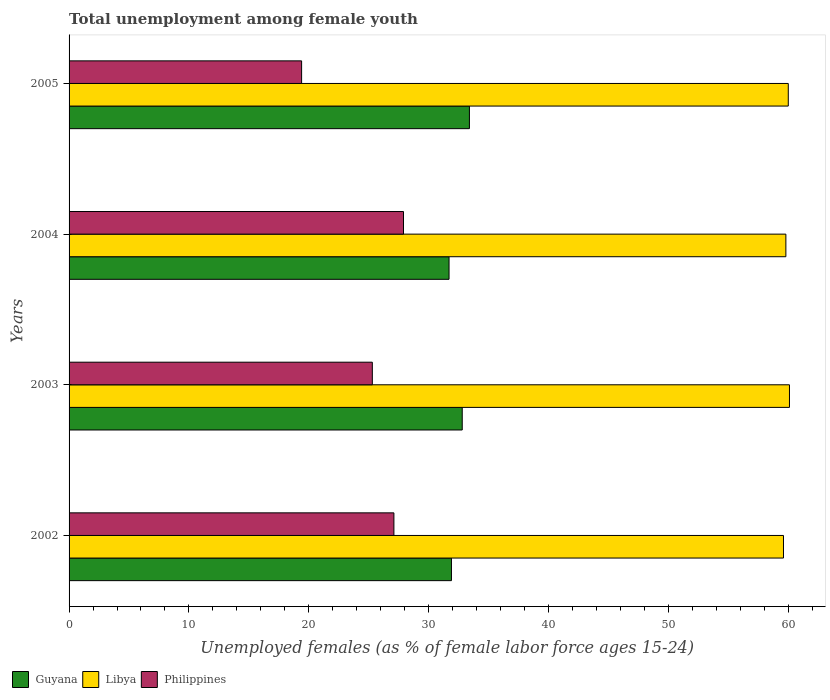How many groups of bars are there?
Make the answer very short. 4. Are the number of bars per tick equal to the number of legend labels?
Your response must be concise. Yes. What is the label of the 4th group of bars from the top?
Make the answer very short. 2002. What is the percentage of unemployed females in in Libya in 2003?
Provide a short and direct response. 60.1. Across all years, what is the maximum percentage of unemployed females in in Guyana?
Make the answer very short. 33.4. Across all years, what is the minimum percentage of unemployed females in in Philippines?
Provide a short and direct response. 19.4. In which year was the percentage of unemployed females in in Libya maximum?
Provide a short and direct response. 2003. What is the total percentage of unemployed females in in Libya in the graph?
Your answer should be compact. 239.5. What is the difference between the percentage of unemployed females in in Philippines in 2003 and that in 2004?
Your answer should be compact. -2.6. What is the average percentage of unemployed females in in Philippines per year?
Make the answer very short. 24.92. In the year 2002, what is the difference between the percentage of unemployed females in in Libya and percentage of unemployed females in in Philippines?
Your response must be concise. 32.5. In how many years, is the percentage of unemployed females in in Guyana greater than 16 %?
Your answer should be very brief. 4. What is the ratio of the percentage of unemployed females in in Guyana in 2003 to that in 2004?
Give a very brief answer. 1.03. Is the difference between the percentage of unemployed females in in Libya in 2002 and 2004 greater than the difference between the percentage of unemployed females in in Philippines in 2002 and 2004?
Your answer should be very brief. Yes. What is the difference between the highest and the second highest percentage of unemployed females in in Philippines?
Offer a terse response. 0.8. What is the difference between the highest and the lowest percentage of unemployed females in in Philippines?
Your answer should be compact. 8.5. In how many years, is the percentage of unemployed females in in Libya greater than the average percentage of unemployed females in in Libya taken over all years?
Keep it short and to the point. 2. Is the sum of the percentage of unemployed females in in Libya in 2003 and 2004 greater than the maximum percentage of unemployed females in in Guyana across all years?
Offer a terse response. Yes. What does the 3rd bar from the top in 2005 represents?
Your answer should be compact. Guyana. What does the 1st bar from the bottom in 2005 represents?
Give a very brief answer. Guyana. How many bars are there?
Offer a very short reply. 12. How many years are there in the graph?
Offer a very short reply. 4. What is the difference between two consecutive major ticks on the X-axis?
Keep it short and to the point. 10. Are the values on the major ticks of X-axis written in scientific E-notation?
Provide a short and direct response. No. Does the graph contain grids?
Give a very brief answer. No. Where does the legend appear in the graph?
Provide a succinct answer. Bottom left. What is the title of the graph?
Give a very brief answer. Total unemployment among female youth. Does "San Marino" appear as one of the legend labels in the graph?
Provide a short and direct response. No. What is the label or title of the X-axis?
Your answer should be very brief. Unemployed females (as % of female labor force ages 15-24). What is the Unemployed females (as % of female labor force ages 15-24) of Guyana in 2002?
Ensure brevity in your answer.  31.9. What is the Unemployed females (as % of female labor force ages 15-24) in Libya in 2002?
Offer a very short reply. 59.6. What is the Unemployed females (as % of female labor force ages 15-24) of Philippines in 2002?
Provide a succinct answer. 27.1. What is the Unemployed females (as % of female labor force ages 15-24) of Guyana in 2003?
Provide a short and direct response. 32.8. What is the Unemployed females (as % of female labor force ages 15-24) in Libya in 2003?
Your answer should be very brief. 60.1. What is the Unemployed females (as % of female labor force ages 15-24) of Philippines in 2003?
Your answer should be compact. 25.3. What is the Unemployed females (as % of female labor force ages 15-24) of Guyana in 2004?
Offer a terse response. 31.7. What is the Unemployed females (as % of female labor force ages 15-24) of Libya in 2004?
Offer a very short reply. 59.8. What is the Unemployed females (as % of female labor force ages 15-24) of Philippines in 2004?
Provide a short and direct response. 27.9. What is the Unemployed females (as % of female labor force ages 15-24) of Guyana in 2005?
Offer a very short reply. 33.4. What is the Unemployed females (as % of female labor force ages 15-24) of Libya in 2005?
Give a very brief answer. 60. What is the Unemployed females (as % of female labor force ages 15-24) of Philippines in 2005?
Ensure brevity in your answer.  19.4. Across all years, what is the maximum Unemployed females (as % of female labor force ages 15-24) in Guyana?
Your response must be concise. 33.4. Across all years, what is the maximum Unemployed females (as % of female labor force ages 15-24) in Libya?
Keep it short and to the point. 60.1. Across all years, what is the maximum Unemployed females (as % of female labor force ages 15-24) in Philippines?
Make the answer very short. 27.9. Across all years, what is the minimum Unemployed females (as % of female labor force ages 15-24) in Guyana?
Offer a very short reply. 31.7. Across all years, what is the minimum Unemployed females (as % of female labor force ages 15-24) in Libya?
Offer a terse response. 59.6. Across all years, what is the minimum Unemployed females (as % of female labor force ages 15-24) of Philippines?
Provide a succinct answer. 19.4. What is the total Unemployed females (as % of female labor force ages 15-24) of Guyana in the graph?
Your answer should be very brief. 129.8. What is the total Unemployed females (as % of female labor force ages 15-24) of Libya in the graph?
Your answer should be very brief. 239.5. What is the total Unemployed females (as % of female labor force ages 15-24) in Philippines in the graph?
Make the answer very short. 99.7. What is the difference between the Unemployed females (as % of female labor force ages 15-24) in Libya in 2002 and that in 2003?
Your answer should be compact. -0.5. What is the difference between the Unemployed females (as % of female labor force ages 15-24) in Libya in 2002 and that in 2004?
Offer a very short reply. -0.2. What is the difference between the Unemployed females (as % of female labor force ages 15-24) in Guyana in 2002 and that in 2005?
Your answer should be very brief. -1.5. What is the difference between the Unemployed females (as % of female labor force ages 15-24) in Philippines in 2002 and that in 2005?
Offer a very short reply. 7.7. What is the difference between the Unemployed females (as % of female labor force ages 15-24) in Guyana in 2003 and that in 2004?
Make the answer very short. 1.1. What is the difference between the Unemployed females (as % of female labor force ages 15-24) of Libya in 2003 and that in 2004?
Provide a succinct answer. 0.3. What is the difference between the Unemployed females (as % of female labor force ages 15-24) of Philippines in 2003 and that in 2004?
Offer a very short reply. -2.6. What is the difference between the Unemployed females (as % of female labor force ages 15-24) in Guyana in 2003 and that in 2005?
Make the answer very short. -0.6. What is the difference between the Unemployed females (as % of female labor force ages 15-24) of Philippines in 2004 and that in 2005?
Offer a very short reply. 8.5. What is the difference between the Unemployed females (as % of female labor force ages 15-24) in Guyana in 2002 and the Unemployed females (as % of female labor force ages 15-24) in Libya in 2003?
Ensure brevity in your answer.  -28.2. What is the difference between the Unemployed females (as % of female labor force ages 15-24) of Libya in 2002 and the Unemployed females (as % of female labor force ages 15-24) of Philippines in 2003?
Keep it short and to the point. 34.3. What is the difference between the Unemployed females (as % of female labor force ages 15-24) of Guyana in 2002 and the Unemployed females (as % of female labor force ages 15-24) of Libya in 2004?
Your response must be concise. -27.9. What is the difference between the Unemployed females (as % of female labor force ages 15-24) in Libya in 2002 and the Unemployed females (as % of female labor force ages 15-24) in Philippines in 2004?
Provide a short and direct response. 31.7. What is the difference between the Unemployed females (as % of female labor force ages 15-24) of Guyana in 2002 and the Unemployed females (as % of female labor force ages 15-24) of Libya in 2005?
Your answer should be very brief. -28.1. What is the difference between the Unemployed females (as % of female labor force ages 15-24) in Guyana in 2002 and the Unemployed females (as % of female labor force ages 15-24) in Philippines in 2005?
Offer a very short reply. 12.5. What is the difference between the Unemployed females (as % of female labor force ages 15-24) in Libya in 2002 and the Unemployed females (as % of female labor force ages 15-24) in Philippines in 2005?
Make the answer very short. 40.2. What is the difference between the Unemployed females (as % of female labor force ages 15-24) in Libya in 2003 and the Unemployed females (as % of female labor force ages 15-24) in Philippines in 2004?
Your answer should be compact. 32.2. What is the difference between the Unemployed females (as % of female labor force ages 15-24) in Guyana in 2003 and the Unemployed females (as % of female labor force ages 15-24) in Libya in 2005?
Make the answer very short. -27.2. What is the difference between the Unemployed females (as % of female labor force ages 15-24) in Guyana in 2003 and the Unemployed females (as % of female labor force ages 15-24) in Philippines in 2005?
Your answer should be very brief. 13.4. What is the difference between the Unemployed females (as % of female labor force ages 15-24) of Libya in 2003 and the Unemployed females (as % of female labor force ages 15-24) of Philippines in 2005?
Your answer should be compact. 40.7. What is the difference between the Unemployed females (as % of female labor force ages 15-24) of Guyana in 2004 and the Unemployed females (as % of female labor force ages 15-24) of Libya in 2005?
Make the answer very short. -28.3. What is the difference between the Unemployed females (as % of female labor force ages 15-24) in Libya in 2004 and the Unemployed females (as % of female labor force ages 15-24) in Philippines in 2005?
Make the answer very short. 40.4. What is the average Unemployed females (as % of female labor force ages 15-24) of Guyana per year?
Make the answer very short. 32.45. What is the average Unemployed females (as % of female labor force ages 15-24) in Libya per year?
Your response must be concise. 59.88. What is the average Unemployed females (as % of female labor force ages 15-24) in Philippines per year?
Your answer should be compact. 24.93. In the year 2002, what is the difference between the Unemployed females (as % of female labor force ages 15-24) of Guyana and Unemployed females (as % of female labor force ages 15-24) of Libya?
Offer a very short reply. -27.7. In the year 2002, what is the difference between the Unemployed females (as % of female labor force ages 15-24) of Guyana and Unemployed females (as % of female labor force ages 15-24) of Philippines?
Offer a very short reply. 4.8. In the year 2002, what is the difference between the Unemployed females (as % of female labor force ages 15-24) of Libya and Unemployed females (as % of female labor force ages 15-24) of Philippines?
Your answer should be compact. 32.5. In the year 2003, what is the difference between the Unemployed females (as % of female labor force ages 15-24) in Guyana and Unemployed females (as % of female labor force ages 15-24) in Libya?
Provide a succinct answer. -27.3. In the year 2003, what is the difference between the Unemployed females (as % of female labor force ages 15-24) in Guyana and Unemployed females (as % of female labor force ages 15-24) in Philippines?
Make the answer very short. 7.5. In the year 2003, what is the difference between the Unemployed females (as % of female labor force ages 15-24) of Libya and Unemployed females (as % of female labor force ages 15-24) of Philippines?
Your response must be concise. 34.8. In the year 2004, what is the difference between the Unemployed females (as % of female labor force ages 15-24) in Guyana and Unemployed females (as % of female labor force ages 15-24) in Libya?
Provide a succinct answer. -28.1. In the year 2004, what is the difference between the Unemployed females (as % of female labor force ages 15-24) of Libya and Unemployed females (as % of female labor force ages 15-24) of Philippines?
Your answer should be very brief. 31.9. In the year 2005, what is the difference between the Unemployed females (as % of female labor force ages 15-24) in Guyana and Unemployed females (as % of female labor force ages 15-24) in Libya?
Your answer should be compact. -26.6. In the year 2005, what is the difference between the Unemployed females (as % of female labor force ages 15-24) in Guyana and Unemployed females (as % of female labor force ages 15-24) in Philippines?
Offer a terse response. 14. In the year 2005, what is the difference between the Unemployed females (as % of female labor force ages 15-24) in Libya and Unemployed females (as % of female labor force ages 15-24) in Philippines?
Provide a succinct answer. 40.6. What is the ratio of the Unemployed females (as % of female labor force ages 15-24) in Guyana in 2002 to that in 2003?
Your answer should be compact. 0.97. What is the ratio of the Unemployed females (as % of female labor force ages 15-24) of Libya in 2002 to that in 2003?
Ensure brevity in your answer.  0.99. What is the ratio of the Unemployed females (as % of female labor force ages 15-24) of Philippines in 2002 to that in 2003?
Offer a terse response. 1.07. What is the ratio of the Unemployed females (as % of female labor force ages 15-24) of Guyana in 2002 to that in 2004?
Make the answer very short. 1.01. What is the ratio of the Unemployed females (as % of female labor force ages 15-24) of Philippines in 2002 to that in 2004?
Offer a very short reply. 0.97. What is the ratio of the Unemployed females (as % of female labor force ages 15-24) of Guyana in 2002 to that in 2005?
Ensure brevity in your answer.  0.96. What is the ratio of the Unemployed females (as % of female labor force ages 15-24) in Philippines in 2002 to that in 2005?
Your response must be concise. 1.4. What is the ratio of the Unemployed females (as % of female labor force ages 15-24) of Guyana in 2003 to that in 2004?
Offer a very short reply. 1.03. What is the ratio of the Unemployed females (as % of female labor force ages 15-24) in Libya in 2003 to that in 2004?
Your answer should be very brief. 1. What is the ratio of the Unemployed females (as % of female labor force ages 15-24) of Philippines in 2003 to that in 2004?
Your response must be concise. 0.91. What is the ratio of the Unemployed females (as % of female labor force ages 15-24) in Guyana in 2003 to that in 2005?
Offer a terse response. 0.98. What is the ratio of the Unemployed females (as % of female labor force ages 15-24) in Philippines in 2003 to that in 2005?
Offer a terse response. 1.3. What is the ratio of the Unemployed females (as % of female labor force ages 15-24) in Guyana in 2004 to that in 2005?
Provide a short and direct response. 0.95. What is the ratio of the Unemployed females (as % of female labor force ages 15-24) in Philippines in 2004 to that in 2005?
Give a very brief answer. 1.44. What is the difference between the highest and the second highest Unemployed females (as % of female labor force ages 15-24) of Guyana?
Make the answer very short. 0.6. What is the difference between the highest and the second highest Unemployed females (as % of female labor force ages 15-24) in Libya?
Your answer should be compact. 0.1. What is the difference between the highest and the second highest Unemployed females (as % of female labor force ages 15-24) of Philippines?
Offer a terse response. 0.8. What is the difference between the highest and the lowest Unemployed females (as % of female labor force ages 15-24) of Libya?
Your answer should be compact. 0.5. What is the difference between the highest and the lowest Unemployed females (as % of female labor force ages 15-24) in Philippines?
Your response must be concise. 8.5. 